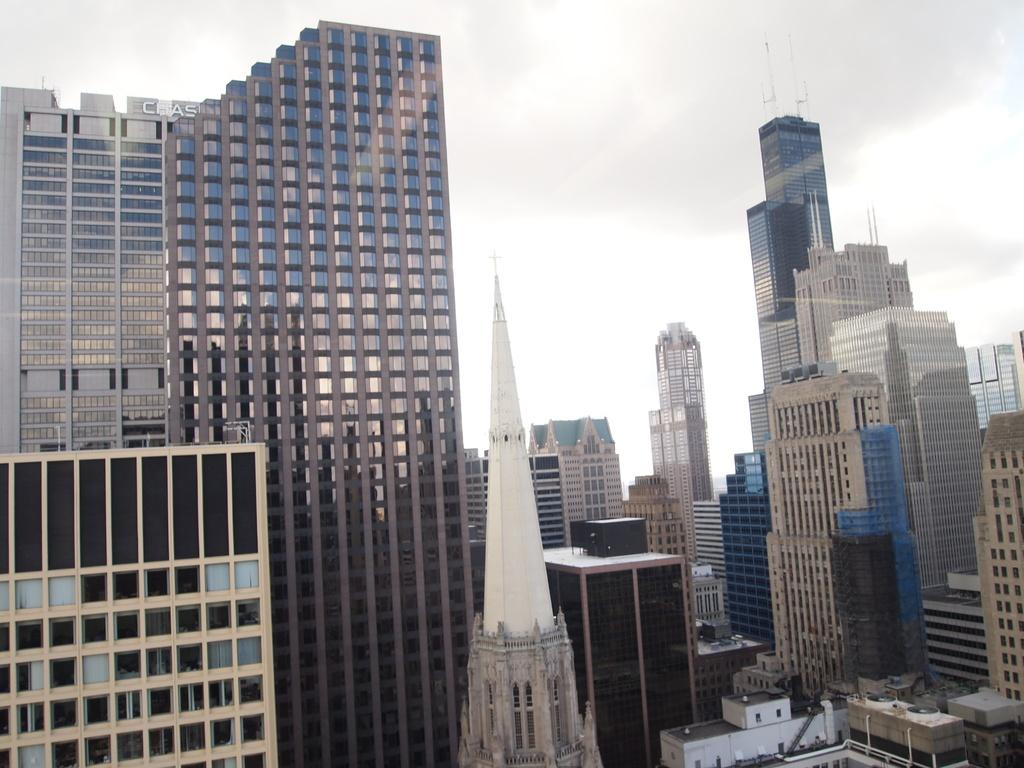What structures are present in the image? There are multiple buildings in the image. What can be seen at the top of the image? The sky is visible at the top of the image. How many people are involved in the fight depicted in the image? There is no fight depicted in the image; it features multiple buildings and the sky. What type of bikes are present in the image? There are no bikes present in the image. 